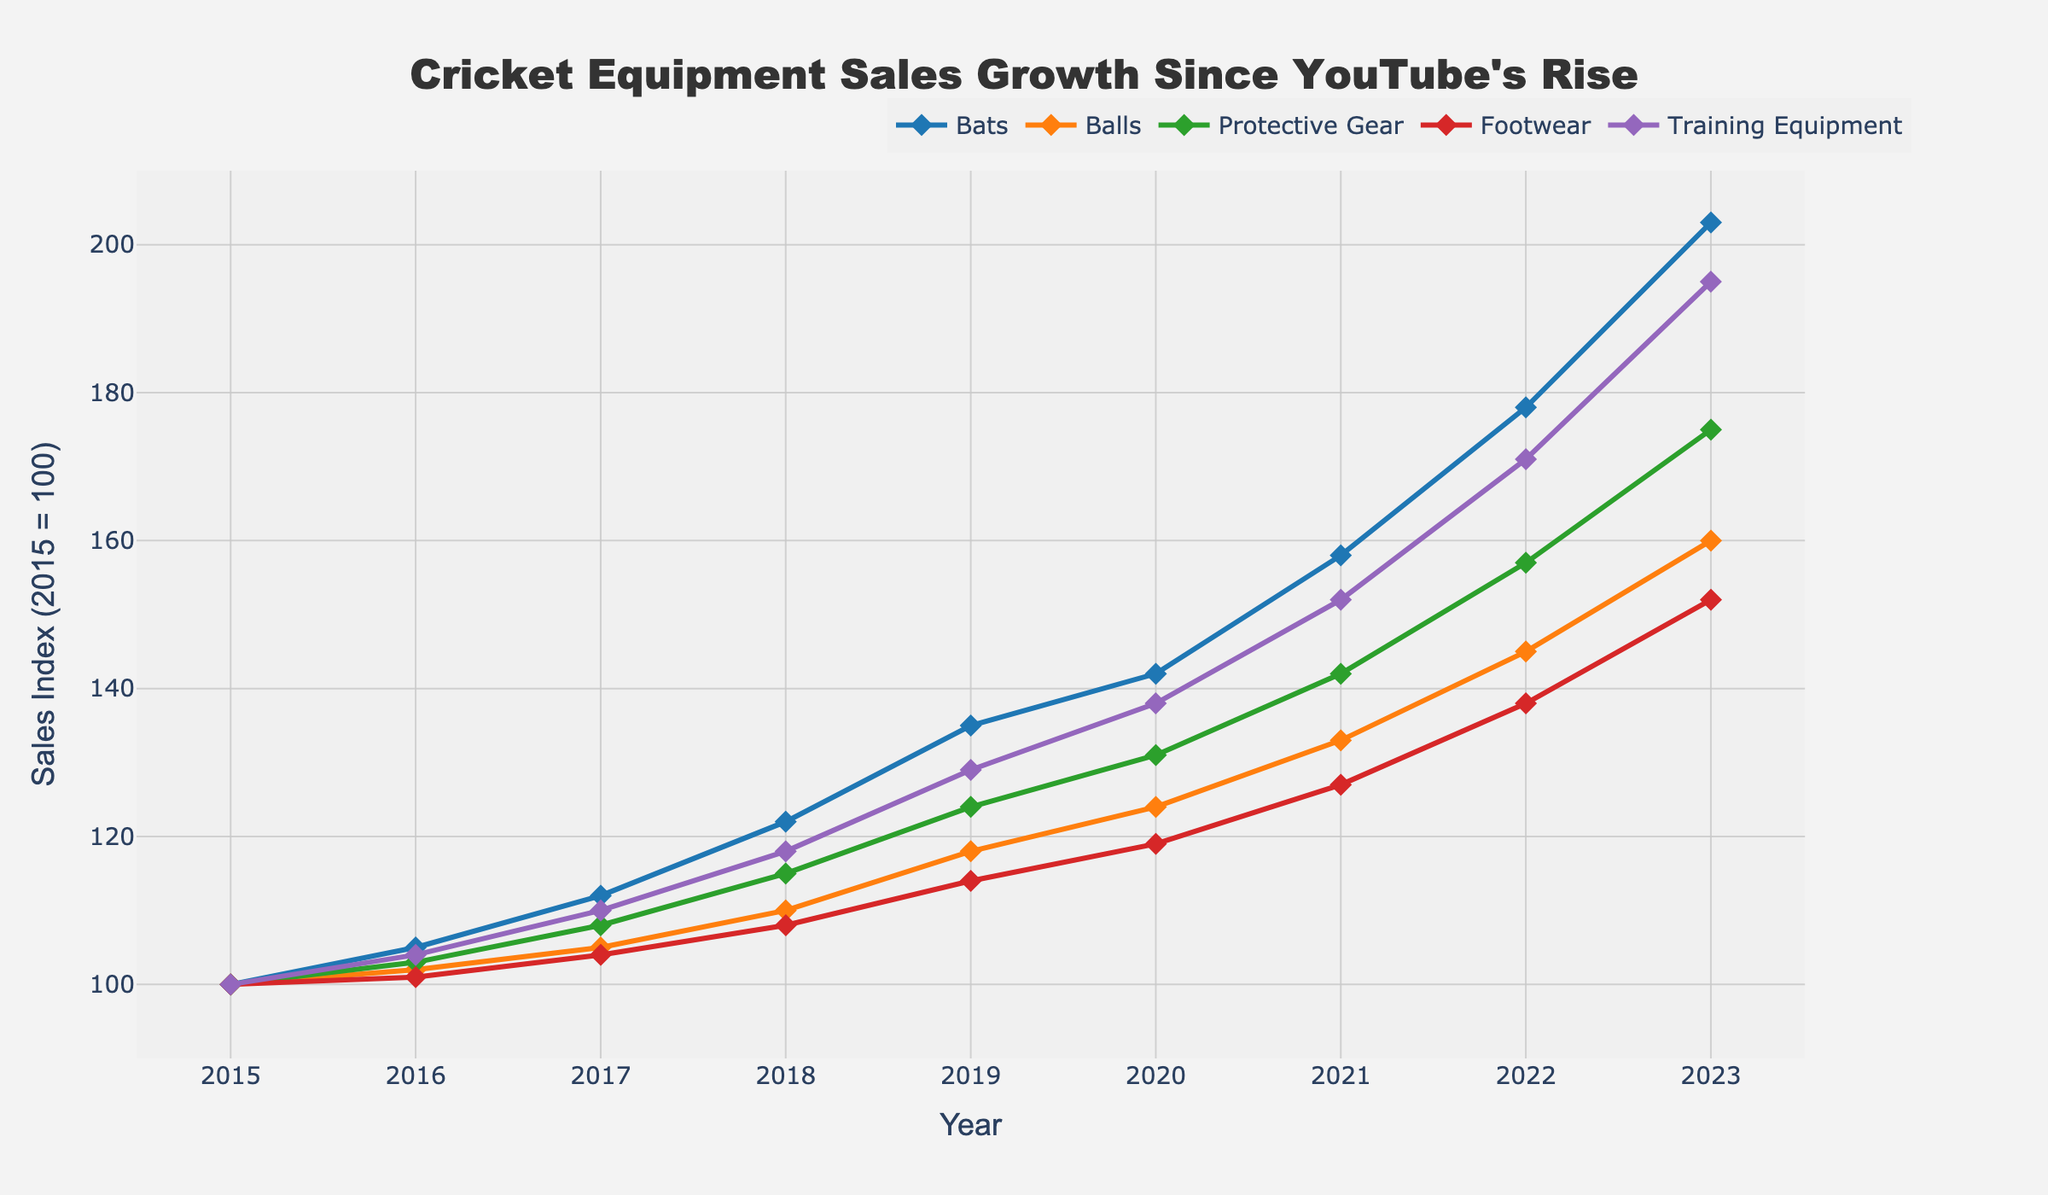Which product category had the highest sales growth from 2015 to 2023? To determine the highest sales growth, observe each product category's sales index in 2015 and 2023. Bats increased from 100 to 203, Balls from 100 to 160, Protective Gear from 100 to 175, Footwear from 100 to 152, and Training Equipment from 100 to 195. The highest growth is 203 - 100 = 103 for Bats.
Answer: Bats How did the sales of Training Equipment change between 2017 and 2019? To find the change, look at the Training Equipment sales index for 2017 (110) and 2019 (129). Calculate the difference: 129 - 110 = 19.
Answer: Increased by 19 In which year did the sales of Protective Gear surpass 130 for the first time? To determine the first year Protective Gear sales surpassed 130, check the yearly data for an index above 130. The index surpasses 130 in 2020 (131).
Answer: 2020 Which product category had the lowest sales index in 2018? To find the category with the lowest sales index, compare the 2018 indices: Bats (122), Balls (110), Protective Gear (115), Footwear (108), and Training Equipment (118). Footwear has the lowest index of 108.
Answer: Footwear How much higher were the sales of Bats in 2023 compared to 2020? To calculate the difference in Bat sales between 2023 and 2020, use their indices: 203 (2023) and 142 (2020). The difference is 203 - 142 = 61.
Answer: 61 Which two product categories experienced the closest sales growth between 2015 and 2023? Calculate the growth for each category: Bats (203-100=103), Balls (160-100=60), Protective Gear (175-100=75), Footwear (152-100=52), Training Equipment (195-100=95). Balls (60) and Footwear (52) are the closest with a difference of 8.
Answer: Balls and Footwear What was the trend for Footwear sales between 2015 and 2023? To determine the trend, observe the yearly sales indices for Footwear. They consistently increase each year from 100 in 2015 to 152 in 2023.
Answer: Increasing By how much did the sales index of Balls increase from 2016 to 2021? To find the increase, look at the indices for Balls in 2016 (102) and 2021 (133). The difference is 133 - 102 = 31.
Answer: 31 Which product showed the fastest growth in sales from 2019 to 2023? Calculate the growth for each product from 2019 to 2023: Bats (203-135=68), Balls (160-118=42), Protective Gear (175-124=51), Footwear (152-114=38), Training Equipment (195-129=66). Bats had the fastest growth of 68.
Answer: Bats 